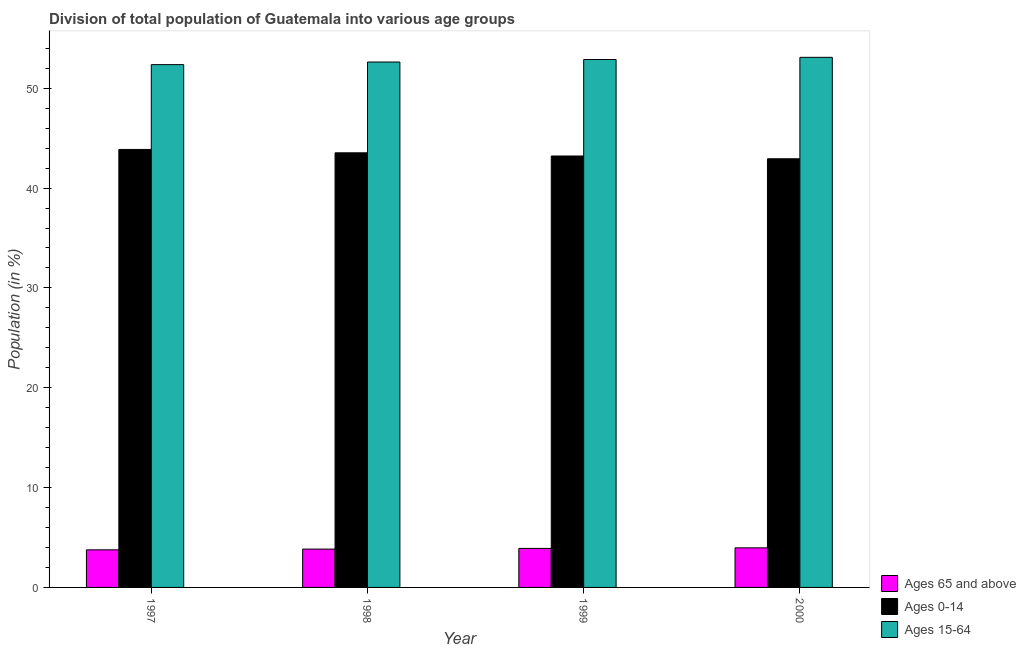How many groups of bars are there?
Your answer should be compact. 4. Are the number of bars per tick equal to the number of legend labels?
Your answer should be compact. Yes. How many bars are there on the 3rd tick from the left?
Provide a succinct answer. 3. What is the percentage of population within the age-group 15-64 in 1997?
Your answer should be very brief. 52.37. Across all years, what is the maximum percentage of population within the age-group of 65 and above?
Give a very brief answer. 3.97. Across all years, what is the minimum percentage of population within the age-group 15-64?
Give a very brief answer. 52.37. In which year was the percentage of population within the age-group of 65 and above minimum?
Offer a very short reply. 1997. What is the total percentage of population within the age-group 0-14 in the graph?
Your answer should be very brief. 173.55. What is the difference between the percentage of population within the age-group of 65 and above in 1997 and that in 2000?
Offer a very short reply. -0.2. What is the difference between the percentage of population within the age-group of 65 and above in 1999 and the percentage of population within the age-group 0-14 in 2000?
Provide a succinct answer. -0.06. What is the average percentage of population within the age-group 0-14 per year?
Offer a very short reply. 43.39. In the year 2000, what is the difference between the percentage of population within the age-group of 65 and above and percentage of population within the age-group 15-64?
Give a very brief answer. 0. In how many years, is the percentage of population within the age-group of 65 and above greater than 6 %?
Offer a very short reply. 0. What is the ratio of the percentage of population within the age-group 0-14 in 1998 to that in 1999?
Keep it short and to the point. 1.01. Is the percentage of population within the age-group 15-64 in 1999 less than that in 2000?
Ensure brevity in your answer.  Yes. What is the difference between the highest and the second highest percentage of population within the age-group 0-14?
Make the answer very short. 0.34. What is the difference between the highest and the lowest percentage of population within the age-group 15-64?
Offer a terse response. 0.73. In how many years, is the percentage of population within the age-group 15-64 greater than the average percentage of population within the age-group 15-64 taken over all years?
Provide a short and direct response. 2. Is the sum of the percentage of population within the age-group 15-64 in 1999 and 2000 greater than the maximum percentage of population within the age-group of 65 and above across all years?
Your response must be concise. Yes. What does the 2nd bar from the left in 1997 represents?
Provide a short and direct response. Ages 0-14. What does the 1st bar from the right in 1997 represents?
Offer a very short reply. Ages 15-64. Is it the case that in every year, the sum of the percentage of population within the age-group of 65 and above and percentage of population within the age-group 0-14 is greater than the percentage of population within the age-group 15-64?
Provide a succinct answer. No. How many bars are there?
Your response must be concise. 12. Are all the bars in the graph horizontal?
Make the answer very short. No. What is the difference between two consecutive major ticks on the Y-axis?
Make the answer very short. 10. What is the title of the graph?
Your answer should be compact. Division of total population of Guatemala into various age groups
. What is the Population (in %) in Ages 65 and above in 1997?
Provide a succinct answer. 3.76. What is the Population (in %) of Ages 0-14 in 1997?
Offer a very short reply. 43.87. What is the Population (in %) in Ages 15-64 in 1997?
Offer a terse response. 52.37. What is the Population (in %) in Ages 65 and above in 1998?
Your answer should be compact. 3.84. What is the Population (in %) of Ages 0-14 in 1998?
Ensure brevity in your answer.  43.53. What is the Population (in %) in Ages 15-64 in 1998?
Ensure brevity in your answer.  52.63. What is the Population (in %) in Ages 65 and above in 1999?
Provide a succinct answer. 3.91. What is the Population (in %) in Ages 0-14 in 1999?
Your response must be concise. 43.21. What is the Population (in %) in Ages 15-64 in 1999?
Your response must be concise. 52.88. What is the Population (in %) in Ages 65 and above in 2000?
Offer a very short reply. 3.97. What is the Population (in %) in Ages 0-14 in 2000?
Make the answer very short. 42.94. What is the Population (in %) in Ages 15-64 in 2000?
Keep it short and to the point. 53.1. Across all years, what is the maximum Population (in %) in Ages 65 and above?
Offer a very short reply. 3.97. Across all years, what is the maximum Population (in %) in Ages 0-14?
Your answer should be compact. 43.87. Across all years, what is the maximum Population (in %) of Ages 15-64?
Provide a short and direct response. 53.1. Across all years, what is the minimum Population (in %) of Ages 65 and above?
Offer a very short reply. 3.76. Across all years, what is the minimum Population (in %) of Ages 0-14?
Ensure brevity in your answer.  42.94. Across all years, what is the minimum Population (in %) of Ages 15-64?
Provide a succinct answer. 52.37. What is the total Population (in %) of Ages 65 and above in the graph?
Your answer should be compact. 15.48. What is the total Population (in %) of Ages 0-14 in the graph?
Give a very brief answer. 173.55. What is the total Population (in %) of Ages 15-64 in the graph?
Your response must be concise. 210.97. What is the difference between the Population (in %) in Ages 65 and above in 1997 and that in 1998?
Your answer should be compact. -0.07. What is the difference between the Population (in %) of Ages 0-14 in 1997 and that in 1998?
Provide a succinct answer. 0.34. What is the difference between the Population (in %) of Ages 15-64 in 1997 and that in 1998?
Give a very brief answer. -0.26. What is the difference between the Population (in %) of Ages 65 and above in 1997 and that in 1999?
Provide a succinct answer. -0.14. What is the difference between the Population (in %) of Ages 0-14 in 1997 and that in 1999?
Give a very brief answer. 0.66. What is the difference between the Population (in %) in Ages 15-64 in 1997 and that in 1999?
Keep it short and to the point. -0.51. What is the difference between the Population (in %) of Ages 65 and above in 1997 and that in 2000?
Your answer should be compact. -0.2. What is the difference between the Population (in %) in Ages 0-14 in 1997 and that in 2000?
Offer a terse response. 0.93. What is the difference between the Population (in %) in Ages 15-64 in 1997 and that in 2000?
Ensure brevity in your answer.  -0.73. What is the difference between the Population (in %) of Ages 65 and above in 1998 and that in 1999?
Your answer should be compact. -0.07. What is the difference between the Population (in %) of Ages 0-14 in 1998 and that in 1999?
Offer a very short reply. 0.32. What is the difference between the Population (in %) in Ages 15-64 in 1998 and that in 1999?
Provide a short and direct response. -0.25. What is the difference between the Population (in %) in Ages 65 and above in 1998 and that in 2000?
Offer a terse response. -0.13. What is the difference between the Population (in %) of Ages 0-14 in 1998 and that in 2000?
Provide a succinct answer. 0.6. What is the difference between the Population (in %) of Ages 15-64 in 1998 and that in 2000?
Offer a very short reply. -0.47. What is the difference between the Population (in %) of Ages 65 and above in 1999 and that in 2000?
Offer a terse response. -0.06. What is the difference between the Population (in %) of Ages 0-14 in 1999 and that in 2000?
Provide a succinct answer. 0.28. What is the difference between the Population (in %) of Ages 15-64 in 1999 and that in 2000?
Give a very brief answer. -0.22. What is the difference between the Population (in %) of Ages 65 and above in 1997 and the Population (in %) of Ages 0-14 in 1998?
Your answer should be very brief. -39.77. What is the difference between the Population (in %) of Ages 65 and above in 1997 and the Population (in %) of Ages 15-64 in 1998?
Your answer should be very brief. -48.86. What is the difference between the Population (in %) of Ages 0-14 in 1997 and the Population (in %) of Ages 15-64 in 1998?
Offer a very short reply. -8.76. What is the difference between the Population (in %) of Ages 65 and above in 1997 and the Population (in %) of Ages 0-14 in 1999?
Your answer should be compact. -39.45. What is the difference between the Population (in %) in Ages 65 and above in 1997 and the Population (in %) in Ages 15-64 in 1999?
Provide a short and direct response. -49.11. What is the difference between the Population (in %) of Ages 0-14 in 1997 and the Population (in %) of Ages 15-64 in 1999?
Give a very brief answer. -9.01. What is the difference between the Population (in %) in Ages 65 and above in 1997 and the Population (in %) in Ages 0-14 in 2000?
Offer a terse response. -39.17. What is the difference between the Population (in %) of Ages 65 and above in 1997 and the Population (in %) of Ages 15-64 in 2000?
Your response must be concise. -49.33. What is the difference between the Population (in %) in Ages 0-14 in 1997 and the Population (in %) in Ages 15-64 in 2000?
Provide a short and direct response. -9.23. What is the difference between the Population (in %) in Ages 65 and above in 1998 and the Population (in %) in Ages 0-14 in 1999?
Offer a terse response. -39.37. What is the difference between the Population (in %) of Ages 65 and above in 1998 and the Population (in %) of Ages 15-64 in 1999?
Make the answer very short. -49.04. What is the difference between the Population (in %) of Ages 0-14 in 1998 and the Population (in %) of Ages 15-64 in 1999?
Your answer should be very brief. -9.35. What is the difference between the Population (in %) in Ages 65 and above in 1998 and the Population (in %) in Ages 0-14 in 2000?
Make the answer very short. -39.1. What is the difference between the Population (in %) of Ages 65 and above in 1998 and the Population (in %) of Ages 15-64 in 2000?
Provide a succinct answer. -49.26. What is the difference between the Population (in %) of Ages 0-14 in 1998 and the Population (in %) of Ages 15-64 in 2000?
Ensure brevity in your answer.  -9.56. What is the difference between the Population (in %) of Ages 65 and above in 1999 and the Population (in %) of Ages 0-14 in 2000?
Ensure brevity in your answer.  -39.03. What is the difference between the Population (in %) in Ages 65 and above in 1999 and the Population (in %) in Ages 15-64 in 2000?
Give a very brief answer. -49.19. What is the difference between the Population (in %) in Ages 0-14 in 1999 and the Population (in %) in Ages 15-64 in 2000?
Give a very brief answer. -9.88. What is the average Population (in %) of Ages 65 and above per year?
Your response must be concise. 3.87. What is the average Population (in %) in Ages 0-14 per year?
Give a very brief answer. 43.39. What is the average Population (in %) in Ages 15-64 per year?
Give a very brief answer. 52.74. In the year 1997, what is the difference between the Population (in %) of Ages 65 and above and Population (in %) of Ages 0-14?
Provide a succinct answer. -40.11. In the year 1997, what is the difference between the Population (in %) in Ages 65 and above and Population (in %) in Ages 15-64?
Keep it short and to the point. -48.6. In the year 1997, what is the difference between the Population (in %) in Ages 0-14 and Population (in %) in Ages 15-64?
Offer a very short reply. -8.49. In the year 1998, what is the difference between the Population (in %) in Ages 65 and above and Population (in %) in Ages 0-14?
Your answer should be very brief. -39.69. In the year 1998, what is the difference between the Population (in %) in Ages 65 and above and Population (in %) in Ages 15-64?
Give a very brief answer. -48.79. In the year 1998, what is the difference between the Population (in %) of Ages 0-14 and Population (in %) of Ages 15-64?
Offer a very short reply. -9.09. In the year 1999, what is the difference between the Population (in %) in Ages 65 and above and Population (in %) in Ages 0-14?
Your response must be concise. -39.31. In the year 1999, what is the difference between the Population (in %) of Ages 65 and above and Population (in %) of Ages 15-64?
Give a very brief answer. -48.97. In the year 1999, what is the difference between the Population (in %) of Ages 0-14 and Population (in %) of Ages 15-64?
Make the answer very short. -9.67. In the year 2000, what is the difference between the Population (in %) of Ages 65 and above and Population (in %) of Ages 0-14?
Your answer should be very brief. -38.97. In the year 2000, what is the difference between the Population (in %) of Ages 65 and above and Population (in %) of Ages 15-64?
Give a very brief answer. -49.13. In the year 2000, what is the difference between the Population (in %) of Ages 0-14 and Population (in %) of Ages 15-64?
Your answer should be very brief. -10.16. What is the ratio of the Population (in %) in Ages 65 and above in 1997 to that in 1998?
Your response must be concise. 0.98. What is the ratio of the Population (in %) in Ages 0-14 in 1997 to that in 1998?
Your answer should be compact. 1.01. What is the ratio of the Population (in %) of Ages 15-64 in 1997 to that in 1998?
Give a very brief answer. 0.99. What is the ratio of the Population (in %) of Ages 65 and above in 1997 to that in 1999?
Offer a very short reply. 0.96. What is the ratio of the Population (in %) of Ages 0-14 in 1997 to that in 1999?
Make the answer very short. 1.02. What is the ratio of the Population (in %) in Ages 15-64 in 1997 to that in 1999?
Keep it short and to the point. 0.99. What is the ratio of the Population (in %) of Ages 65 and above in 1997 to that in 2000?
Keep it short and to the point. 0.95. What is the ratio of the Population (in %) of Ages 0-14 in 1997 to that in 2000?
Offer a very short reply. 1.02. What is the ratio of the Population (in %) in Ages 15-64 in 1997 to that in 2000?
Give a very brief answer. 0.99. What is the ratio of the Population (in %) in Ages 65 and above in 1998 to that in 1999?
Your answer should be very brief. 0.98. What is the ratio of the Population (in %) of Ages 0-14 in 1998 to that in 1999?
Make the answer very short. 1.01. What is the ratio of the Population (in %) of Ages 65 and above in 1998 to that in 2000?
Ensure brevity in your answer.  0.97. What is the ratio of the Population (in %) of Ages 0-14 in 1998 to that in 2000?
Give a very brief answer. 1.01. What is the ratio of the Population (in %) in Ages 15-64 in 1998 to that in 2000?
Provide a short and direct response. 0.99. What is the ratio of the Population (in %) in Ages 65 and above in 1999 to that in 2000?
Offer a terse response. 0.99. What is the ratio of the Population (in %) in Ages 0-14 in 1999 to that in 2000?
Your answer should be compact. 1.01. What is the ratio of the Population (in %) in Ages 15-64 in 1999 to that in 2000?
Provide a succinct answer. 1. What is the difference between the highest and the second highest Population (in %) of Ages 65 and above?
Provide a short and direct response. 0.06. What is the difference between the highest and the second highest Population (in %) of Ages 0-14?
Provide a short and direct response. 0.34. What is the difference between the highest and the second highest Population (in %) of Ages 15-64?
Keep it short and to the point. 0.22. What is the difference between the highest and the lowest Population (in %) of Ages 65 and above?
Your answer should be compact. 0.2. What is the difference between the highest and the lowest Population (in %) of Ages 0-14?
Offer a very short reply. 0.93. What is the difference between the highest and the lowest Population (in %) of Ages 15-64?
Ensure brevity in your answer.  0.73. 